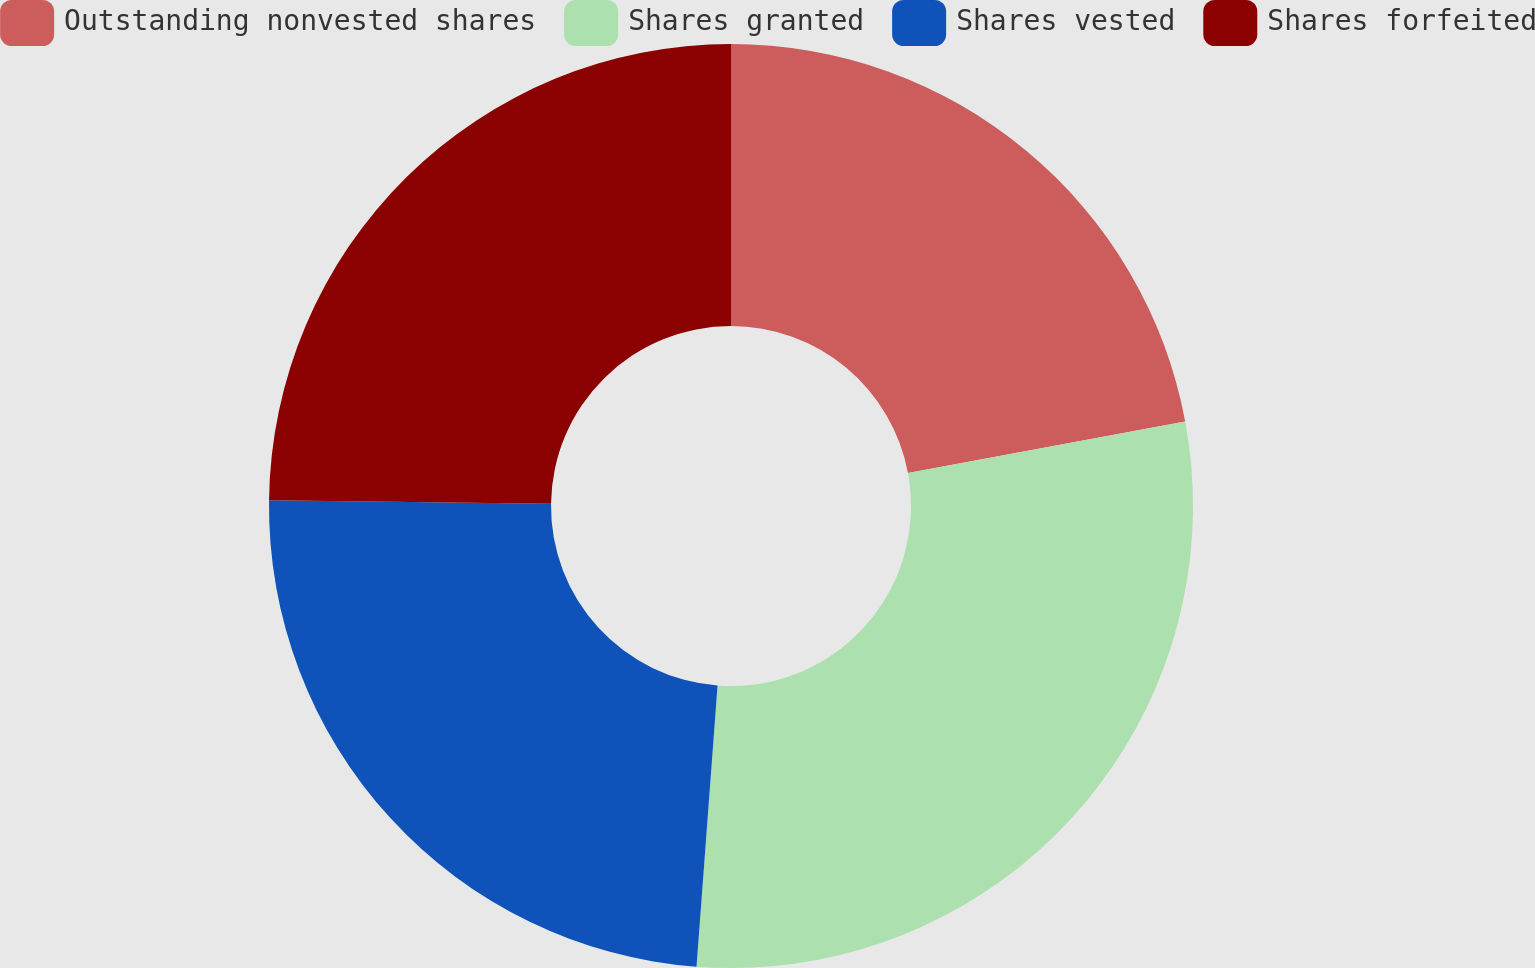Convert chart to OTSL. <chart><loc_0><loc_0><loc_500><loc_500><pie_chart><fcel>Outstanding nonvested shares<fcel>Shares granted<fcel>Shares vested<fcel>Shares forfeited<nl><fcel>22.07%<fcel>29.12%<fcel>24.01%<fcel>24.8%<nl></chart> 